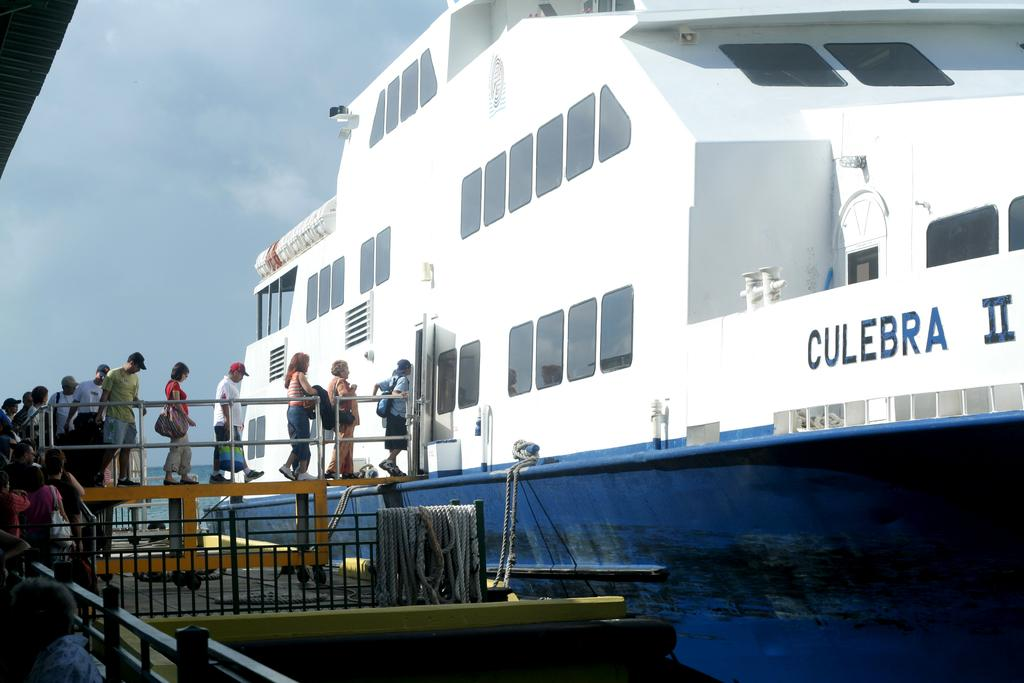What is the main subject of the image? The main subject of the image is a ship. Are there any people present in the image? Yes, there are people in the image. What other structures or objects can be seen in the image? There is a bridge, metal railing, and a rope in the image. What is visible in the background of the image? The sky is visible in the image. What type of mint can be seen growing near the ship in the image? There is no mint present in the image; it features a ship, people, a bridge, metal railing, a rope, and the sky. 